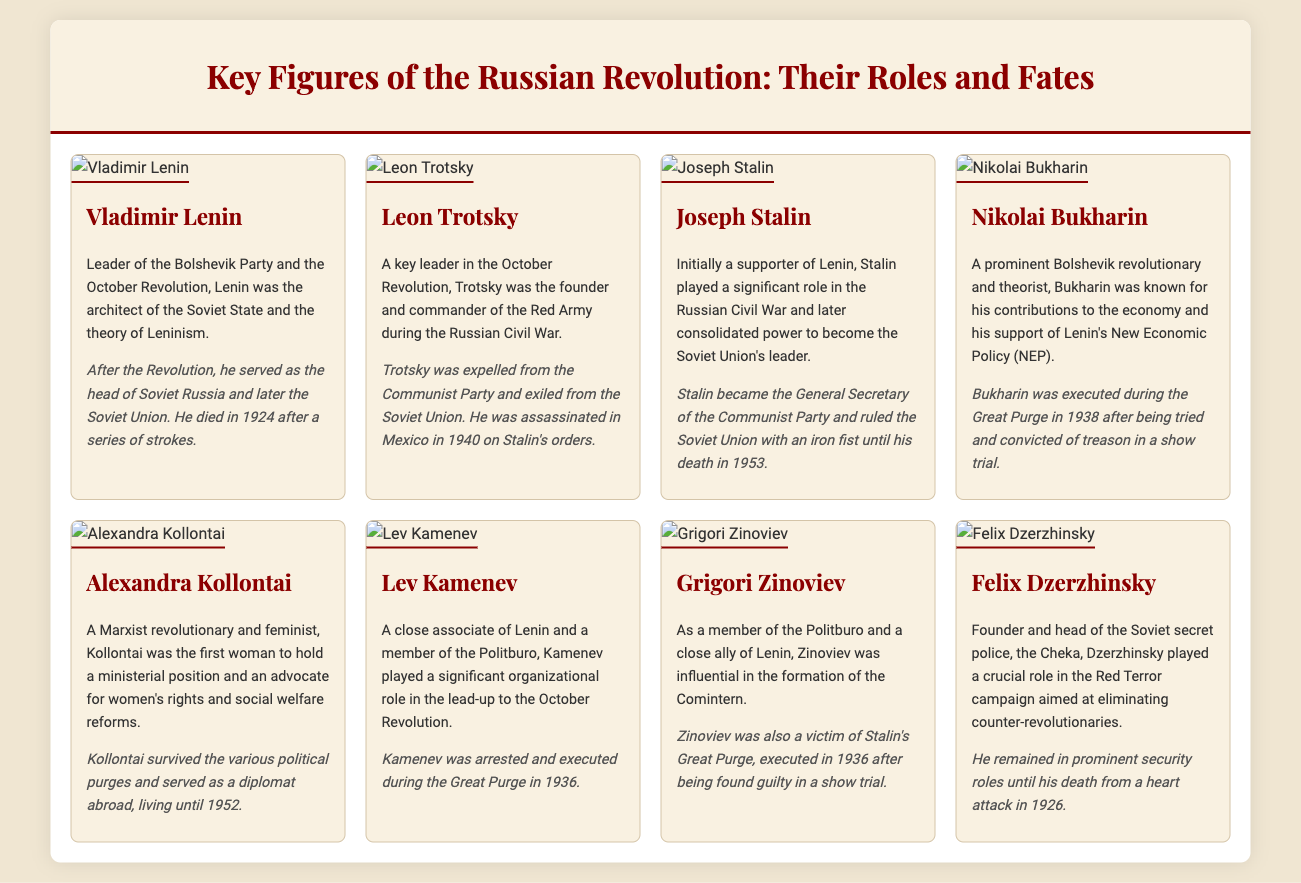What was Lenin's role in the Russian Revolution? Lenin was the leader of the Bolshevik Party and the architect of the Soviet State.
Answer: Leader of the Bolshevik Party Who was the founder of the Red Army? Trotsky was the founder and commander of the Red Army during the Russian Civil War.
Answer: Leon Trotsky What year did Lenin die? Lenin died in 1924 after a series of strokes.
Answer: 1924 What was Joseph Stalin's title in the Communist Party? Stalin became the General Secretary of the Communist Party.
Answer: General Secretary How did Nikolai Bukharin die? Bukharin was executed during the Great Purge in 1938.
Answer: Executed in 1938 Which figure was the first woman to hold a ministerial position? Alexandra Kollontai was the first woman to hold a ministerial position.
Answer: Alexandra Kollontai What prominent role did Felix Dzerzhinsky serve in? Dzerzhinsky was the founder and head of the Soviet secret police, the Cheka.
Answer: Head of the Cheka Which two figures were executed during the Great Purge in 1936? Both Lev Kamenev and Grigori Zinoviev were executed during the Great Purge.
Answer: Lev Kamenev and Grigori Zinoviev 